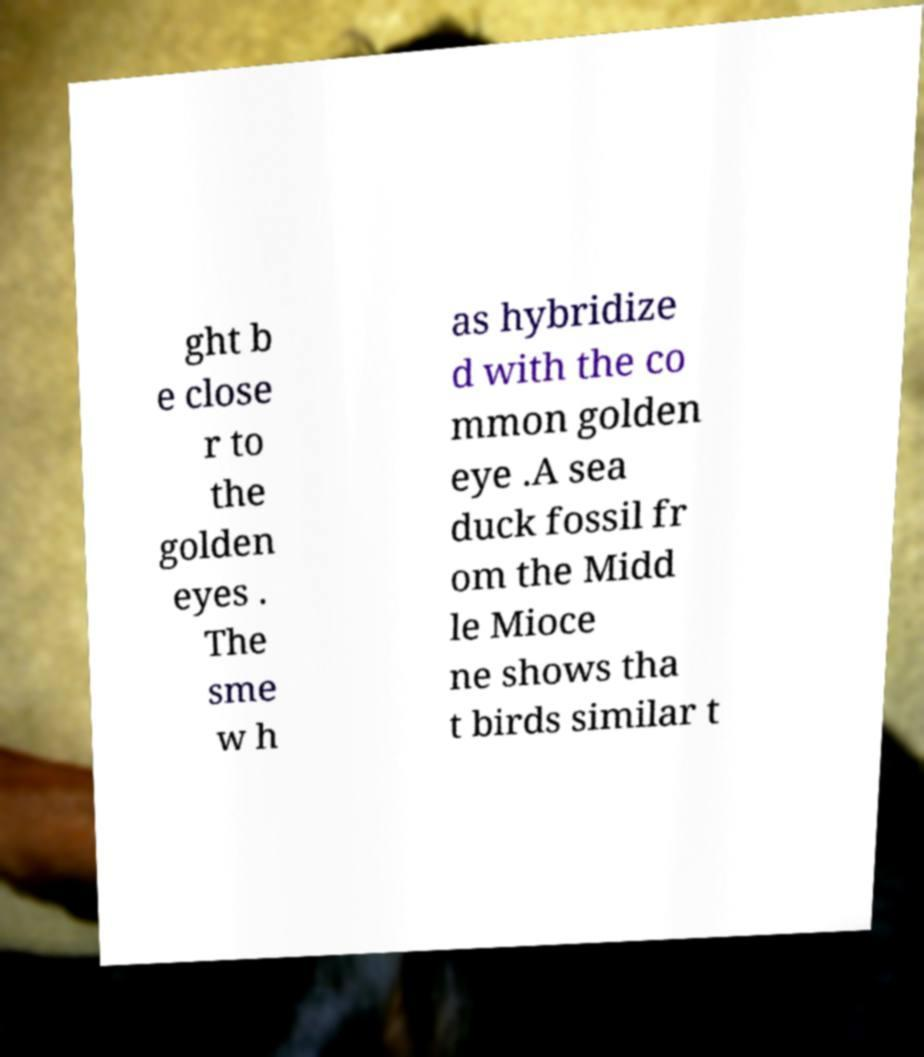Could you assist in decoding the text presented in this image and type it out clearly? ght b e close r to the golden eyes . The sme w h as hybridize d with the co mmon golden eye .A sea duck fossil fr om the Midd le Mioce ne shows tha t birds similar t 